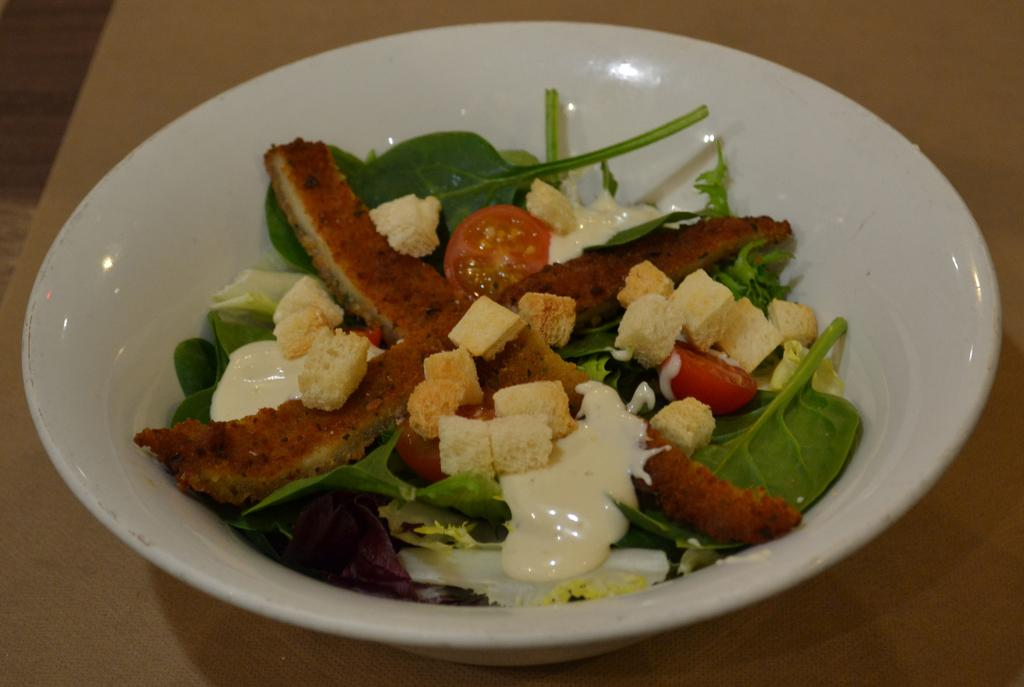What color is the bowl that is visible in the image? The bowl is white. What is inside the bowl in the image? The bowl contains food items. Where is the bowl located in the image? The bowl is placed on a table. Can you see any birds walking in the cellar in the image? There are no birds or cellars present in the image; it features a white bowl with food items on a table. 